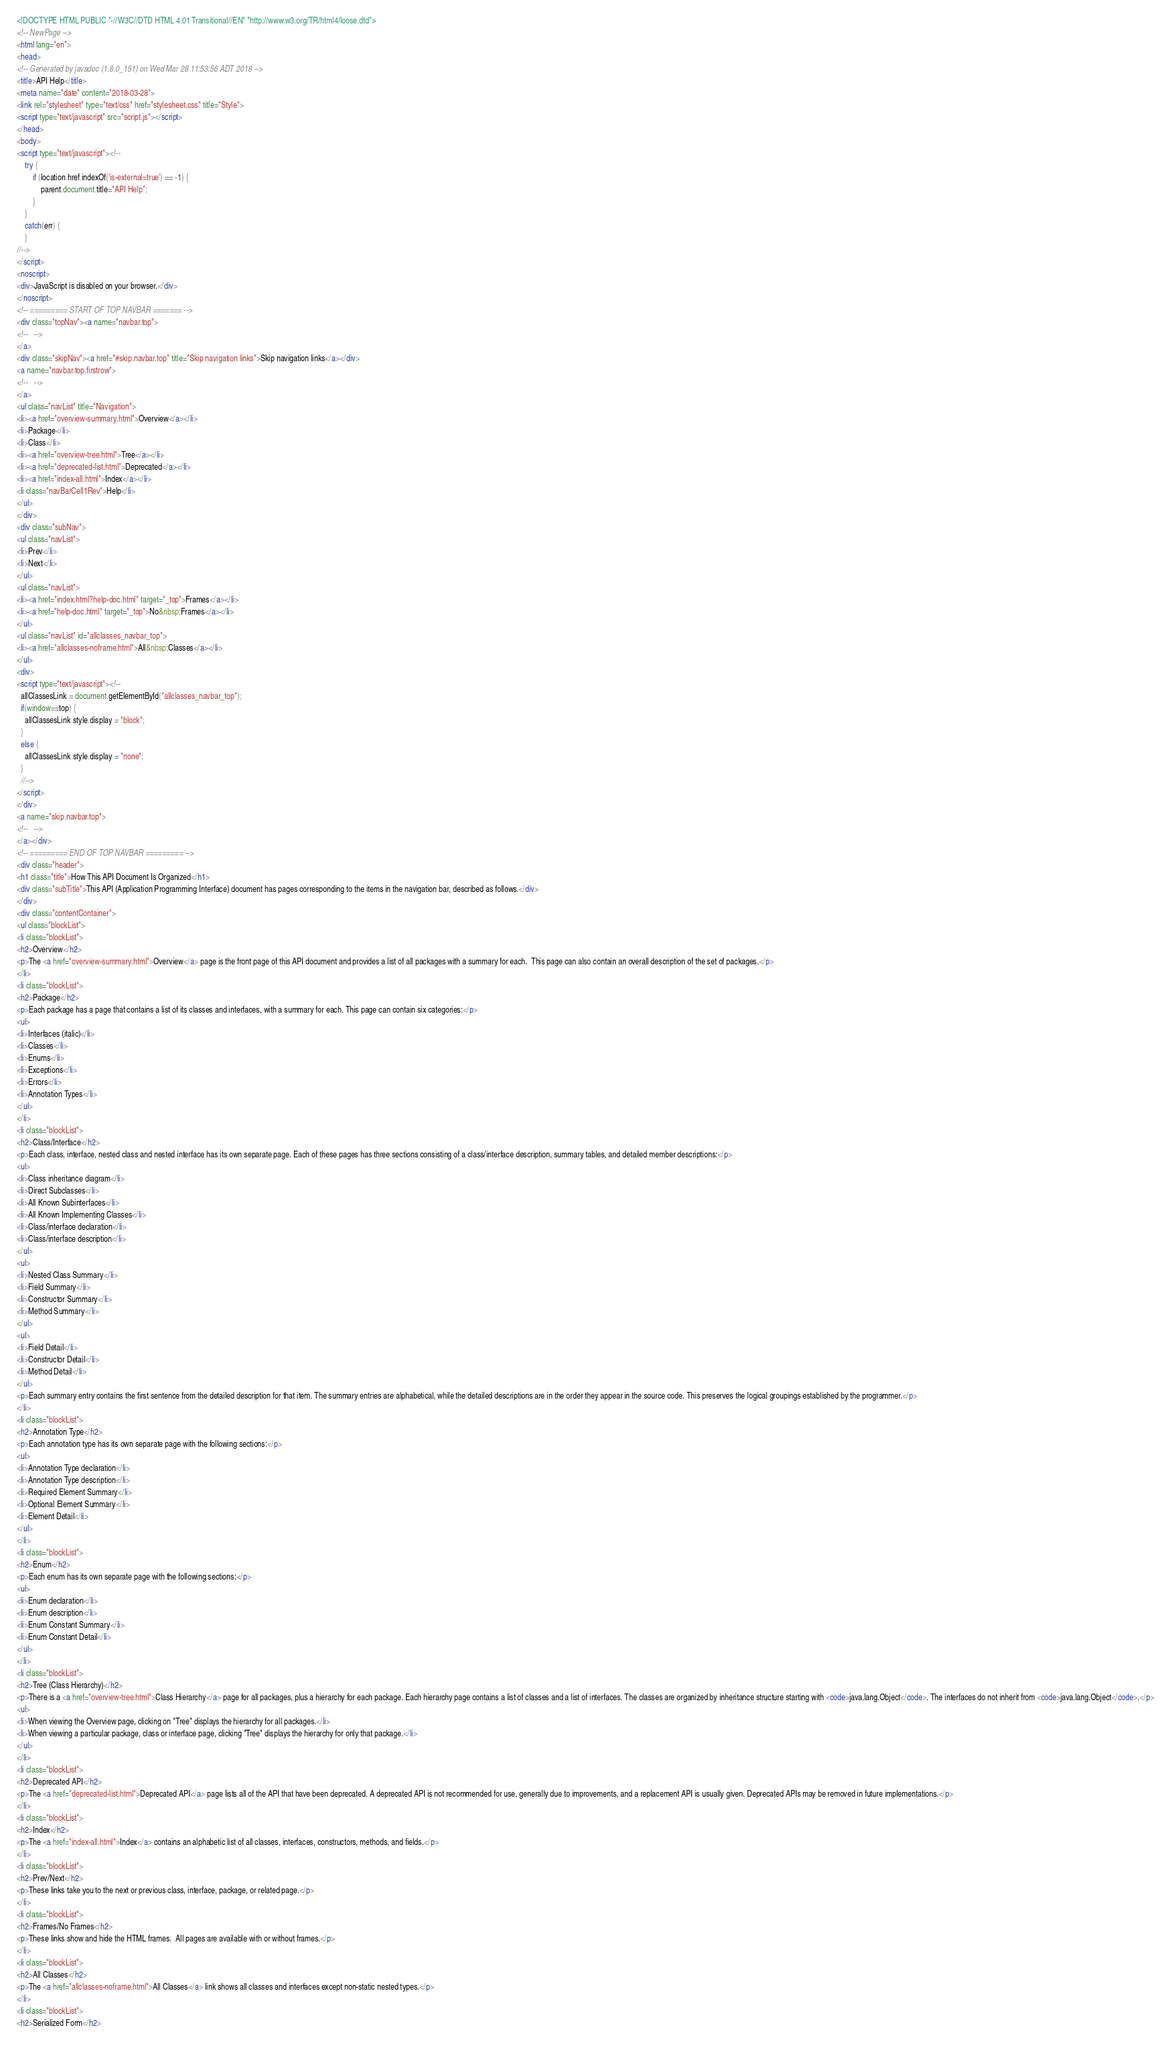Convert code to text. <code><loc_0><loc_0><loc_500><loc_500><_HTML_><!DOCTYPE HTML PUBLIC "-//W3C//DTD HTML 4.01 Transitional//EN" "http://www.w3.org/TR/html4/loose.dtd">
<!-- NewPage -->
<html lang="en">
<head>
<!-- Generated by javadoc (1.8.0_151) on Wed Mar 28 11:53:56 ADT 2018 -->
<title>API Help</title>
<meta name="date" content="2018-03-28">
<link rel="stylesheet" type="text/css" href="stylesheet.css" title="Style">
<script type="text/javascript" src="script.js"></script>
</head>
<body>
<script type="text/javascript"><!--
    try {
        if (location.href.indexOf('is-external=true') == -1) {
            parent.document.title="API Help";
        }
    }
    catch(err) {
    }
//-->
</script>
<noscript>
<div>JavaScript is disabled on your browser.</div>
</noscript>
<!-- ========= START OF TOP NAVBAR ======= -->
<div class="topNav"><a name="navbar.top">
<!--   -->
</a>
<div class="skipNav"><a href="#skip.navbar.top" title="Skip navigation links">Skip navigation links</a></div>
<a name="navbar.top.firstrow">
<!--   -->
</a>
<ul class="navList" title="Navigation">
<li><a href="overview-summary.html">Overview</a></li>
<li>Package</li>
<li>Class</li>
<li><a href="overview-tree.html">Tree</a></li>
<li><a href="deprecated-list.html">Deprecated</a></li>
<li><a href="index-all.html">Index</a></li>
<li class="navBarCell1Rev">Help</li>
</ul>
</div>
<div class="subNav">
<ul class="navList">
<li>Prev</li>
<li>Next</li>
</ul>
<ul class="navList">
<li><a href="index.html?help-doc.html" target="_top">Frames</a></li>
<li><a href="help-doc.html" target="_top">No&nbsp;Frames</a></li>
</ul>
<ul class="navList" id="allclasses_navbar_top">
<li><a href="allclasses-noframe.html">All&nbsp;Classes</a></li>
</ul>
<div>
<script type="text/javascript"><!--
  allClassesLink = document.getElementById("allclasses_navbar_top");
  if(window==top) {
    allClassesLink.style.display = "block";
  }
  else {
    allClassesLink.style.display = "none";
  }
  //-->
</script>
</div>
<a name="skip.navbar.top">
<!--   -->
</a></div>
<!-- ========= END OF TOP NAVBAR ========= -->
<div class="header">
<h1 class="title">How This API Document Is Organized</h1>
<div class="subTitle">This API (Application Programming Interface) document has pages corresponding to the items in the navigation bar, described as follows.</div>
</div>
<div class="contentContainer">
<ul class="blockList">
<li class="blockList">
<h2>Overview</h2>
<p>The <a href="overview-summary.html">Overview</a> page is the front page of this API document and provides a list of all packages with a summary for each.  This page can also contain an overall description of the set of packages.</p>
</li>
<li class="blockList">
<h2>Package</h2>
<p>Each package has a page that contains a list of its classes and interfaces, with a summary for each. This page can contain six categories:</p>
<ul>
<li>Interfaces (italic)</li>
<li>Classes</li>
<li>Enums</li>
<li>Exceptions</li>
<li>Errors</li>
<li>Annotation Types</li>
</ul>
</li>
<li class="blockList">
<h2>Class/Interface</h2>
<p>Each class, interface, nested class and nested interface has its own separate page. Each of these pages has three sections consisting of a class/interface description, summary tables, and detailed member descriptions:</p>
<ul>
<li>Class inheritance diagram</li>
<li>Direct Subclasses</li>
<li>All Known Subinterfaces</li>
<li>All Known Implementing Classes</li>
<li>Class/interface declaration</li>
<li>Class/interface description</li>
</ul>
<ul>
<li>Nested Class Summary</li>
<li>Field Summary</li>
<li>Constructor Summary</li>
<li>Method Summary</li>
</ul>
<ul>
<li>Field Detail</li>
<li>Constructor Detail</li>
<li>Method Detail</li>
</ul>
<p>Each summary entry contains the first sentence from the detailed description for that item. The summary entries are alphabetical, while the detailed descriptions are in the order they appear in the source code. This preserves the logical groupings established by the programmer.</p>
</li>
<li class="blockList">
<h2>Annotation Type</h2>
<p>Each annotation type has its own separate page with the following sections:</p>
<ul>
<li>Annotation Type declaration</li>
<li>Annotation Type description</li>
<li>Required Element Summary</li>
<li>Optional Element Summary</li>
<li>Element Detail</li>
</ul>
</li>
<li class="blockList">
<h2>Enum</h2>
<p>Each enum has its own separate page with the following sections:</p>
<ul>
<li>Enum declaration</li>
<li>Enum description</li>
<li>Enum Constant Summary</li>
<li>Enum Constant Detail</li>
</ul>
</li>
<li class="blockList">
<h2>Tree (Class Hierarchy)</h2>
<p>There is a <a href="overview-tree.html">Class Hierarchy</a> page for all packages, plus a hierarchy for each package. Each hierarchy page contains a list of classes and a list of interfaces. The classes are organized by inheritance structure starting with <code>java.lang.Object</code>. The interfaces do not inherit from <code>java.lang.Object</code>.</p>
<ul>
<li>When viewing the Overview page, clicking on "Tree" displays the hierarchy for all packages.</li>
<li>When viewing a particular package, class or interface page, clicking "Tree" displays the hierarchy for only that package.</li>
</ul>
</li>
<li class="blockList">
<h2>Deprecated API</h2>
<p>The <a href="deprecated-list.html">Deprecated API</a> page lists all of the API that have been deprecated. A deprecated API is not recommended for use, generally due to improvements, and a replacement API is usually given. Deprecated APIs may be removed in future implementations.</p>
</li>
<li class="blockList">
<h2>Index</h2>
<p>The <a href="index-all.html">Index</a> contains an alphabetic list of all classes, interfaces, constructors, methods, and fields.</p>
</li>
<li class="blockList">
<h2>Prev/Next</h2>
<p>These links take you to the next or previous class, interface, package, or related page.</p>
</li>
<li class="blockList">
<h2>Frames/No Frames</h2>
<p>These links show and hide the HTML frames.  All pages are available with or without frames.</p>
</li>
<li class="blockList">
<h2>All Classes</h2>
<p>The <a href="allclasses-noframe.html">All Classes</a> link shows all classes and interfaces except non-static nested types.</p>
</li>
<li class="blockList">
<h2>Serialized Form</h2></code> 